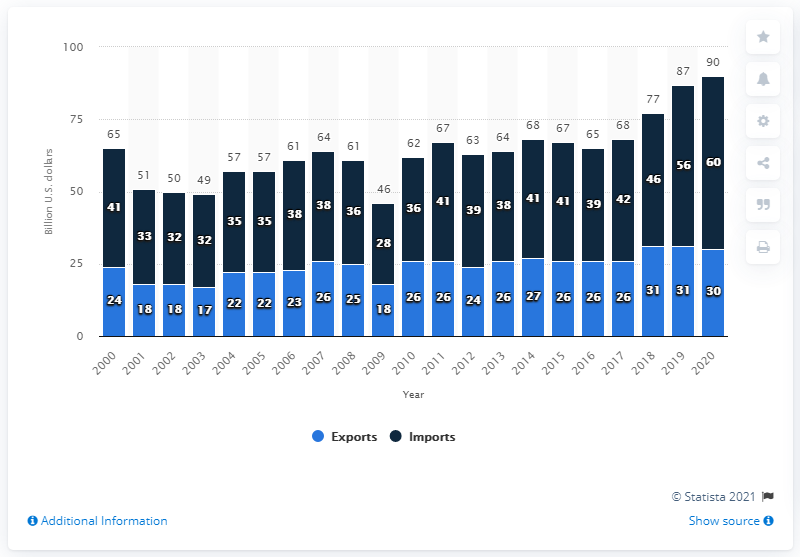Identify some key points in this picture. In 2020, a total of 60 million U.S. dollars worth of goods were imported from Taiwan. The difference between the highest and the lowest dark blue bar is 32. The lowest value of the blue bar is 17. 